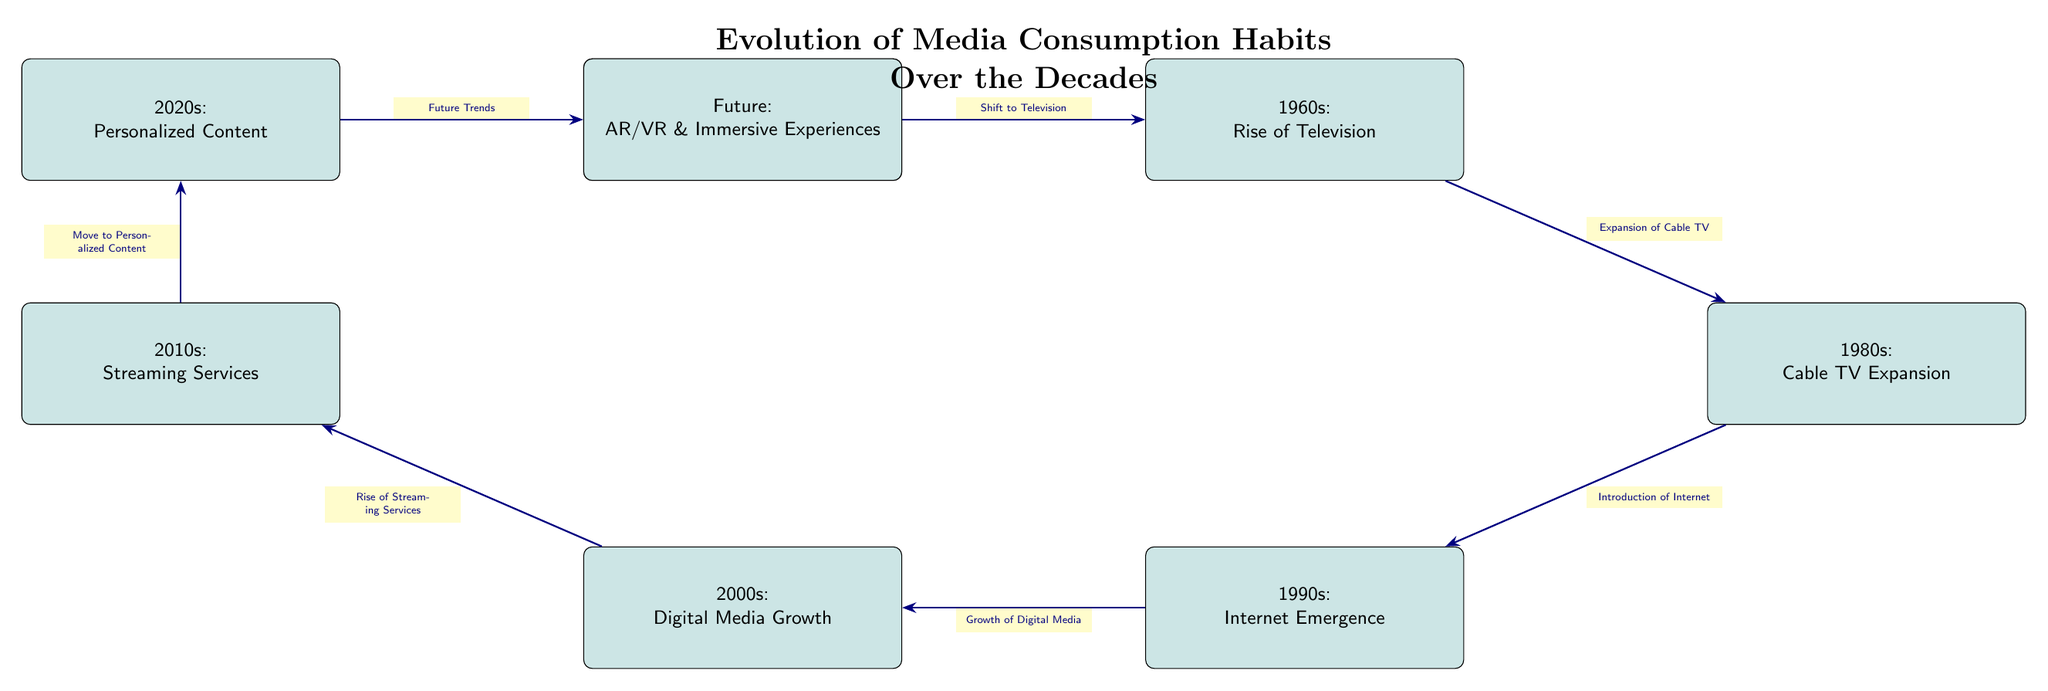What was the dominant media in the 1950s? The diagram specifies that the 1950s were characterized by "Print Media Dominance."
Answer: Print Media Dominance What trend shifted media consumption from the 1950s to the 1960s? The diagram uses the phrase "Shift to Television" to indicate the transition in media consumption habits between the two decades.
Answer: Shift to Television How many major media phases are depicted in the diagram? By counting the boxes in the diagram, there are a total of 8 phases of media consumption habits.
Answer: 8 What significant development occurred in the 1990s? The diagram clearly states that the 1990s saw the "Internet Emergence" as a key trend in media consumption habits.
Answer: Internet Emergence What trend is projected for the future of media consumption? The diagram outlines that the future trend is focused on "AR/VR & Immersive Experiences."
Answer: AR/VR & Immersive Experiences What is the connection between the 2000s and 2010s trends? According to the diagram, there is a clear link where the "Growth of Digital Media" in the 2000s leads to the "Rise of Streaming Services" in the 2010s.
Answer: Growth of Digital Media leading to Rise of Streaming Services Which decade introduced the concept of personalized content? The diagram states that personalized content became prominent in the 2020s, as indicated in the respective box.
Answer: 2020s What was the transition from the 1980s to the 1990s? The arrow detail in the diagram states that the "Introduction of Internet" marked the transition from the "Cable TV Expansion" of the 1980s to the 1990s.
Answer: Introduction of Internet What was a major factor in the transition from the 2010s to the 2020s? The diagram indicates that the "Move to Personalized Content" was the primary factor for change between the 2010s and 2020s.
Answer: Move to Personalized Content 